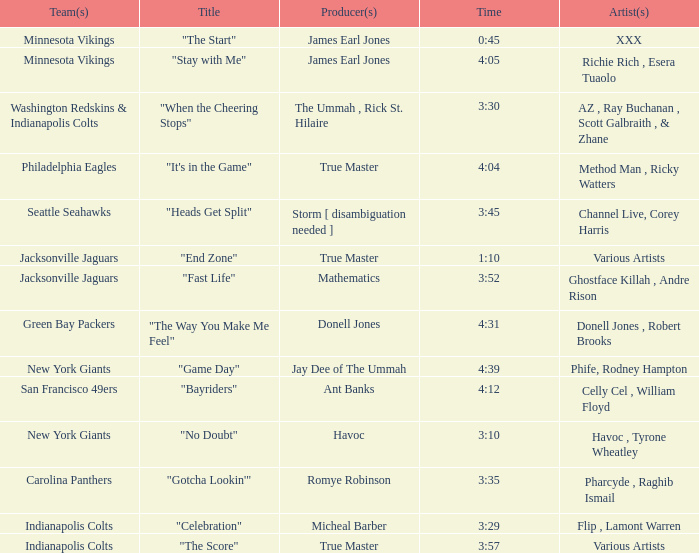What teams used a track 3:29 long? Indianapolis Colts. 